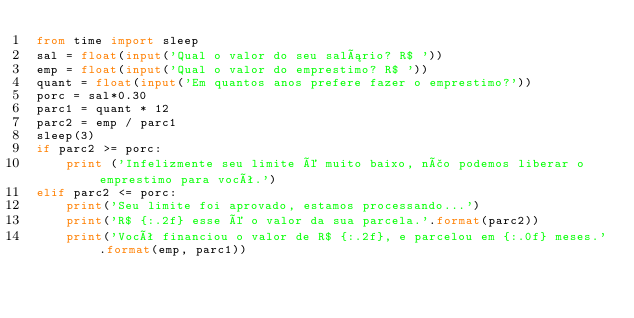Convert code to text. <code><loc_0><loc_0><loc_500><loc_500><_Python_>from time import sleep
sal = float(input('Qual o valor do seu salário? R$ '))
emp = float(input('Qual o valor do emprestimo? R$ '))
quant = float(input('Em quantos anos prefere fazer o emprestimo?'))
porc = sal*0.30
parc1 = quant * 12
parc2 = emp / parc1
sleep(3)
if parc2 >= porc:
    print ('Infelizmente seu limite é muito baixo, não podemos liberar o emprestimo para você.')
elif parc2 <= porc:
    print('Seu limite foi aprovado, estamos processando...')
    print('R$ {:.2f} esse é o valor da sua parcela.'.format(parc2))
    print('Você financiou o valor de R$ {:.2f}, e parcelou em {:.0f} meses.'.format(emp, parc1))
</code> 